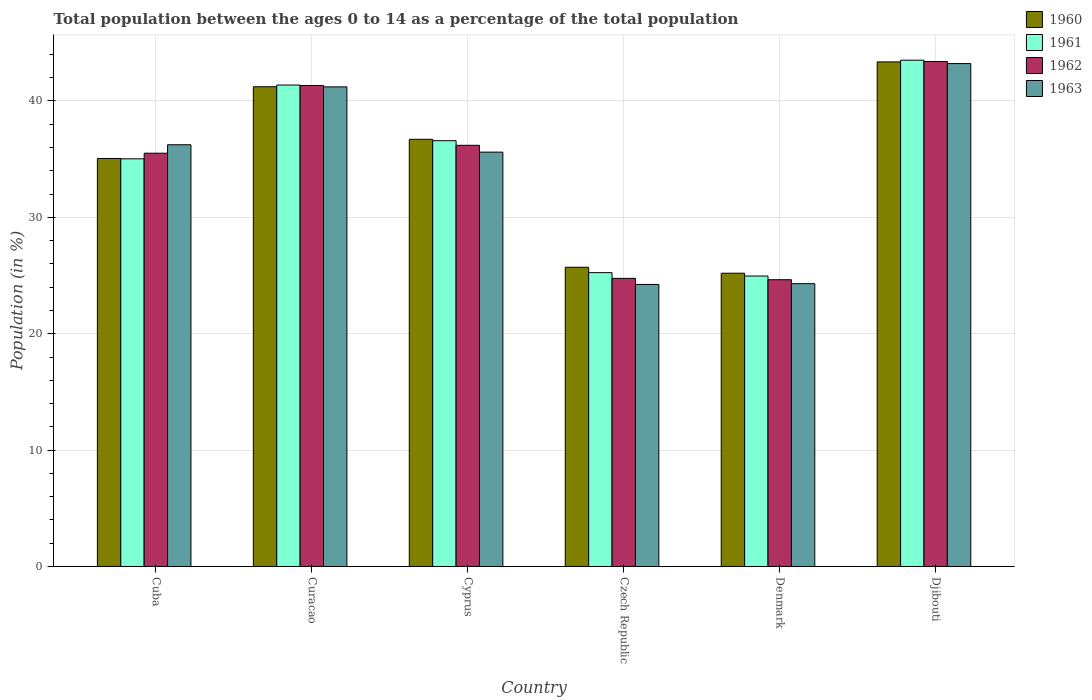How many different coloured bars are there?
Ensure brevity in your answer.  4. How many groups of bars are there?
Ensure brevity in your answer.  6. How many bars are there on the 4th tick from the left?
Provide a succinct answer. 4. How many bars are there on the 6th tick from the right?
Your response must be concise. 4. What is the label of the 1st group of bars from the left?
Keep it short and to the point. Cuba. What is the percentage of the population ages 0 to 14 in 1963 in Cyprus?
Your answer should be compact. 35.6. Across all countries, what is the maximum percentage of the population ages 0 to 14 in 1962?
Your response must be concise. 43.39. Across all countries, what is the minimum percentage of the population ages 0 to 14 in 1961?
Your answer should be very brief. 24.96. In which country was the percentage of the population ages 0 to 14 in 1961 maximum?
Provide a short and direct response. Djibouti. What is the total percentage of the population ages 0 to 14 in 1961 in the graph?
Your answer should be compact. 206.7. What is the difference between the percentage of the population ages 0 to 14 in 1963 in Curacao and that in Djibouti?
Make the answer very short. -2. What is the difference between the percentage of the population ages 0 to 14 in 1963 in Cyprus and the percentage of the population ages 0 to 14 in 1961 in Curacao?
Provide a short and direct response. -5.77. What is the average percentage of the population ages 0 to 14 in 1960 per country?
Make the answer very short. 34.54. What is the difference between the percentage of the population ages 0 to 14 of/in 1961 and percentage of the population ages 0 to 14 of/in 1960 in Cuba?
Offer a very short reply. -0.03. In how many countries, is the percentage of the population ages 0 to 14 in 1963 greater than 10?
Make the answer very short. 6. What is the ratio of the percentage of the population ages 0 to 14 in 1962 in Cuba to that in Cyprus?
Keep it short and to the point. 0.98. Is the percentage of the population ages 0 to 14 in 1963 in Cyprus less than that in Czech Republic?
Offer a very short reply. No. Is the difference between the percentage of the population ages 0 to 14 in 1961 in Czech Republic and Denmark greater than the difference between the percentage of the population ages 0 to 14 in 1960 in Czech Republic and Denmark?
Keep it short and to the point. No. What is the difference between the highest and the second highest percentage of the population ages 0 to 14 in 1963?
Offer a terse response. -2. What is the difference between the highest and the lowest percentage of the population ages 0 to 14 in 1961?
Make the answer very short. 18.55. Is it the case that in every country, the sum of the percentage of the population ages 0 to 14 in 1960 and percentage of the population ages 0 to 14 in 1961 is greater than the sum of percentage of the population ages 0 to 14 in 1962 and percentage of the population ages 0 to 14 in 1963?
Offer a terse response. No. What does the 1st bar from the left in Cuba represents?
Your response must be concise. 1960. What does the 4th bar from the right in Czech Republic represents?
Make the answer very short. 1960. Are all the bars in the graph horizontal?
Offer a very short reply. No. How many countries are there in the graph?
Provide a succinct answer. 6. What is the difference between two consecutive major ticks on the Y-axis?
Keep it short and to the point. 10. What is the title of the graph?
Your response must be concise. Total population between the ages 0 to 14 as a percentage of the total population. Does "1995" appear as one of the legend labels in the graph?
Keep it short and to the point. No. What is the label or title of the X-axis?
Ensure brevity in your answer.  Country. What is the label or title of the Y-axis?
Your answer should be very brief. Population (in %). What is the Population (in %) of 1960 in Cuba?
Make the answer very short. 35.06. What is the Population (in %) in 1961 in Cuba?
Provide a succinct answer. 35.03. What is the Population (in %) of 1962 in Cuba?
Your answer should be compact. 35.51. What is the Population (in %) in 1963 in Cuba?
Offer a terse response. 36.24. What is the Population (in %) of 1960 in Curacao?
Ensure brevity in your answer.  41.22. What is the Population (in %) of 1961 in Curacao?
Your response must be concise. 41.37. What is the Population (in %) of 1962 in Curacao?
Make the answer very short. 41.33. What is the Population (in %) in 1963 in Curacao?
Ensure brevity in your answer.  41.21. What is the Population (in %) in 1960 in Cyprus?
Make the answer very short. 36.71. What is the Population (in %) in 1961 in Cyprus?
Your answer should be compact. 36.59. What is the Population (in %) of 1962 in Cyprus?
Your response must be concise. 36.19. What is the Population (in %) in 1963 in Cyprus?
Provide a short and direct response. 35.6. What is the Population (in %) of 1960 in Czech Republic?
Your answer should be compact. 25.71. What is the Population (in %) of 1961 in Czech Republic?
Ensure brevity in your answer.  25.25. What is the Population (in %) in 1962 in Czech Republic?
Provide a succinct answer. 24.76. What is the Population (in %) in 1963 in Czech Republic?
Make the answer very short. 24.23. What is the Population (in %) in 1960 in Denmark?
Keep it short and to the point. 25.2. What is the Population (in %) in 1961 in Denmark?
Give a very brief answer. 24.96. What is the Population (in %) in 1962 in Denmark?
Make the answer very short. 24.64. What is the Population (in %) of 1963 in Denmark?
Your answer should be very brief. 24.3. What is the Population (in %) in 1960 in Djibouti?
Offer a very short reply. 43.36. What is the Population (in %) in 1961 in Djibouti?
Offer a very short reply. 43.5. What is the Population (in %) of 1962 in Djibouti?
Offer a very short reply. 43.39. What is the Population (in %) of 1963 in Djibouti?
Your response must be concise. 43.21. Across all countries, what is the maximum Population (in %) of 1960?
Ensure brevity in your answer.  43.36. Across all countries, what is the maximum Population (in %) in 1961?
Give a very brief answer. 43.5. Across all countries, what is the maximum Population (in %) in 1962?
Offer a terse response. 43.39. Across all countries, what is the maximum Population (in %) of 1963?
Provide a short and direct response. 43.21. Across all countries, what is the minimum Population (in %) in 1960?
Provide a short and direct response. 25.2. Across all countries, what is the minimum Population (in %) of 1961?
Make the answer very short. 24.96. Across all countries, what is the minimum Population (in %) in 1962?
Make the answer very short. 24.64. Across all countries, what is the minimum Population (in %) in 1963?
Your answer should be compact. 24.23. What is the total Population (in %) in 1960 in the graph?
Your answer should be compact. 207.26. What is the total Population (in %) in 1961 in the graph?
Your answer should be very brief. 206.7. What is the total Population (in %) of 1962 in the graph?
Make the answer very short. 205.82. What is the total Population (in %) of 1963 in the graph?
Provide a succinct answer. 204.8. What is the difference between the Population (in %) in 1960 in Cuba and that in Curacao?
Provide a succinct answer. -6.16. What is the difference between the Population (in %) in 1961 in Cuba and that in Curacao?
Offer a very short reply. -6.34. What is the difference between the Population (in %) in 1962 in Cuba and that in Curacao?
Your answer should be compact. -5.82. What is the difference between the Population (in %) of 1963 in Cuba and that in Curacao?
Give a very brief answer. -4.97. What is the difference between the Population (in %) of 1960 in Cuba and that in Cyprus?
Provide a short and direct response. -1.65. What is the difference between the Population (in %) in 1961 in Cuba and that in Cyprus?
Ensure brevity in your answer.  -1.56. What is the difference between the Population (in %) in 1962 in Cuba and that in Cyprus?
Provide a short and direct response. -0.68. What is the difference between the Population (in %) of 1963 in Cuba and that in Cyprus?
Keep it short and to the point. 0.63. What is the difference between the Population (in %) of 1960 in Cuba and that in Czech Republic?
Keep it short and to the point. 9.35. What is the difference between the Population (in %) in 1961 in Cuba and that in Czech Republic?
Offer a very short reply. 9.78. What is the difference between the Population (in %) in 1962 in Cuba and that in Czech Republic?
Offer a terse response. 10.76. What is the difference between the Population (in %) of 1963 in Cuba and that in Czech Republic?
Make the answer very short. 12. What is the difference between the Population (in %) in 1960 in Cuba and that in Denmark?
Make the answer very short. 9.86. What is the difference between the Population (in %) of 1961 in Cuba and that in Denmark?
Give a very brief answer. 10.07. What is the difference between the Population (in %) of 1962 in Cuba and that in Denmark?
Provide a short and direct response. 10.87. What is the difference between the Population (in %) of 1963 in Cuba and that in Denmark?
Give a very brief answer. 11.94. What is the difference between the Population (in %) of 1960 in Cuba and that in Djibouti?
Ensure brevity in your answer.  -8.3. What is the difference between the Population (in %) in 1961 in Cuba and that in Djibouti?
Offer a terse response. -8.48. What is the difference between the Population (in %) of 1962 in Cuba and that in Djibouti?
Provide a succinct answer. -7.88. What is the difference between the Population (in %) of 1963 in Cuba and that in Djibouti?
Your response must be concise. -6.97. What is the difference between the Population (in %) in 1960 in Curacao and that in Cyprus?
Give a very brief answer. 4.52. What is the difference between the Population (in %) of 1961 in Curacao and that in Cyprus?
Your response must be concise. 4.78. What is the difference between the Population (in %) of 1962 in Curacao and that in Cyprus?
Make the answer very short. 5.14. What is the difference between the Population (in %) in 1963 in Curacao and that in Cyprus?
Your answer should be very brief. 5.61. What is the difference between the Population (in %) in 1960 in Curacao and that in Czech Republic?
Make the answer very short. 15.51. What is the difference between the Population (in %) in 1961 in Curacao and that in Czech Republic?
Ensure brevity in your answer.  16.12. What is the difference between the Population (in %) of 1962 in Curacao and that in Czech Republic?
Your answer should be very brief. 16.57. What is the difference between the Population (in %) of 1963 in Curacao and that in Czech Republic?
Provide a short and direct response. 16.98. What is the difference between the Population (in %) in 1960 in Curacao and that in Denmark?
Your answer should be compact. 16.02. What is the difference between the Population (in %) of 1961 in Curacao and that in Denmark?
Your answer should be very brief. 16.41. What is the difference between the Population (in %) of 1962 in Curacao and that in Denmark?
Offer a terse response. 16.69. What is the difference between the Population (in %) of 1963 in Curacao and that in Denmark?
Your response must be concise. 16.91. What is the difference between the Population (in %) of 1960 in Curacao and that in Djibouti?
Give a very brief answer. -2.14. What is the difference between the Population (in %) of 1961 in Curacao and that in Djibouti?
Provide a succinct answer. -2.13. What is the difference between the Population (in %) of 1962 in Curacao and that in Djibouti?
Keep it short and to the point. -2.06. What is the difference between the Population (in %) of 1963 in Curacao and that in Djibouti?
Offer a very short reply. -2. What is the difference between the Population (in %) of 1960 in Cyprus and that in Czech Republic?
Keep it short and to the point. 11. What is the difference between the Population (in %) of 1961 in Cyprus and that in Czech Republic?
Provide a short and direct response. 11.34. What is the difference between the Population (in %) in 1962 in Cyprus and that in Czech Republic?
Ensure brevity in your answer.  11.43. What is the difference between the Population (in %) of 1963 in Cyprus and that in Czech Republic?
Make the answer very short. 11.37. What is the difference between the Population (in %) of 1960 in Cyprus and that in Denmark?
Provide a short and direct response. 11.51. What is the difference between the Population (in %) of 1961 in Cyprus and that in Denmark?
Ensure brevity in your answer.  11.63. What is the difference between the Population (in %) in 1962 in Cyprus and that in Denmark?
Offer a very short reply. 11.55. What is the difference between the Population (in %) in 1963 in Cyprus and that in Denmark?
Provide a succinct answer. 11.3. What is the difference between the Population (in %) in 1960 in Cyprus and that in Djibouti?
Make the answer very short. -6.65. What is the difference between the Population (in %) in 1961 in Cyprus and that in Djibouti?
Provide a short and direct response. -6.92. What is the difference between the Population (in %) in 1962 in Cyprus and that in Djibouti?
Your answer should be very brief. -7.2. What is the difference between the Population (in %) of 1963 in Cyprus and that in Djibouti?
Provide a succinct answer. -7.61. What is the difference between the Population (in %) in 1960 in Czech Republic and that in Denmark?
Your answer should be compact. 0.51. What is the difference between the Population (in %) in 1961 in Czech Republic and that in Denmark?
Offer a very short reply. 0.29. What is the difference between the Population (in %) of 1962 in Czech Republic and that in Denmark?
Make the answer very short. 0.12. What is the difference between the Population (in %) in 1963 in Czech Republic and that in Denmark?
Ensure brevity in your answer.  -0.07. What is the difference between the Population (in %) in 1960 in Czech Republic and that in Djibouti?
Offer a terse response. -17.65. What is the difference between the Population (in %) in 1961 in Czech Republic and that in Djibouti?
Offer a terse response. -18.26. What is the difference between the Population (in %) of 1962 in Czech Republic and that in Djibouti?
Provide a short and direct response. -18.64. What is the difference between the Population (in %) in 1963 in Czech Republic and that in Djibouti?
Ensure brevity in your answer.  -18.98. What is the difference between the Population (in %) of 1960 in Denmark and that in Djibouti?
Ensure brevity in your answer.  -18.16. What is the difference between the Population (in %) of 1961 in Denmark and that in Djibouti?
Provide a succinct answer. -18.55. What is the difference between the Population (in %) of 1962 in Denmark and that in Djibouti?
Make the answer very short. -18.75. What is the difference between the Population (in %) of 1963 in Denmark and that in Djibouti?
Offer a very short reply. -18.91. What is the difference between the Population (in %) in 1960 in Cuba and the Population (in %) in 1961 in Curacao?
Your response must be concise. -6.31. What is the difference between the Population (in %) in 1960 in Cuba and the Population (in %) in 1962 in Curacao?
Your answer should be compact. -6.27. What is the difference between the Population (in %) in 1960 in Cuba and the Population (in %) in 1963 in Curacao?
Offer a very short reply. -6.15. What is the difference between the Population (in %) of 1961 in Cuba and the Population (in %) of 1962 in Curacao?
Keep it short and to the point. -6.3. What is the difference between the Population (in %) of 1961 in Cuba and the Population (in %) of 1963 in Curacao?
Keep it short and to the point. -6.18. What is the difference between the Population (in %) of 1960 in Cuba and the Population (in %) of 1961 in Cyprus?
Offer a very short reply. -1.53. What is the difference between the Population (in %) of 1960 in Cuba and the Population (in %) of 1962 in Cyprus?
Make the answer very short. -1.13. What is the difference between the Population (in %) in 1960 in Cuba and the Population (in %) in 1963 in Cyprus?
Keep it short and to the point. -0.54. What is the difference between the Population (in %) in 1961 in Cuba and the Population (in %) in 1962 in Cyprus?
Ensure brevity in your answer.  -1.16. What is the difference between the Population (in %) in 1961 in Cuba and the Population (in %) in 1963 in Cyprus?
Offer a very short reply. -0.58. What is the difference between the Population (in %) of 1962 in Cuba and the Population (in %) of 1963 in Cyprus?
Offer a very short reply. -0.09. What is the difference between the Population (in %) in 1960 in Cuba and the Population (in %) in 1961 in Czech Republic?
Your answer should be compact. 9.81. What is the difference between the Population (in %) in 1960 in Cuba and the Population (in %) in 1962 in Czech Republic?
Your response must be concise. 10.3. What is the difference between the Population (in %) of 1960 in Cuba and the Population (in %) of 1963 in Czech Republic?
Your response must be concise. 10.83. What is the difference between the Population (in %) of 1961 in Cuba and the Population (in %) of 1962 in Czech Republic?
Provide a short and direct response. 10.27. What is the difference between the Population (in %) in 1961 in Cuba and the Population (in %) in 1963 in Czech Republic?
Make the answer very short. 10.79. What is the difference between the Population (in %) of 1962 in Cuba and the Population (in %) of 1963 in Czech Republic?
Your response must be concise. 11.28. What is the difference between the Population (in %) of 1960 in Cuba and the Population (in %) of 1961 in Denmark?
Give a very brief answer. 10.1. What is the difference between the Population (in %) of 1960 in Cuba and the Population (in %) of 1962 in Denmark?
Keep it short and to the point. 10.42. What is the difference between the Population (in %) in 1960 in Cuba and the Population (in %) in 1963 in Denmark?
Your response must be concise. 10.76. What is the difference between the Population (in %) in 1961 in Cuba and the Population (in %) in 1962 in Denmark?
Your answer should be very brief. 10.39. What is the difference between the Population (in %) in 1961 in Cuba and the Population (in %) in 1963 in Denmark?
Your response must be concise. 10.73. What is the difference between the Population (in %) in 1962 in Cuba and the Population (in %) in 1963 in Denmark?
Offer a very short reply. 11.21. What is the difference between the Population (in %) of 1960 in Cuba and the Population (in %) of 1961 in Djibouti?
Offer a very short reply. -8.44. What is the difference between the Population (in %) of 1960 in Cuba and the Population (in %) of 1962 in Djibouti?
Provide a short and direct response. -8.33. What is the difference between the Population (in %) of 1960 in Cuba and the Population (in %) of 1963 in Djibouti?
Your answer should be very brief. -8.15. What is the difference between the Population (in %) of 1961 in Cuba and the Population (in %) of 1962 in Djibouti?
Your response must be concise. -8.36. What is the difference between the Population (in %) of 1961 in Cuba and the Population (in %) of 1963 in Djibouti?
Keep it short and to the point. -8.18. What is the difference between the Population (in %) in 1962 in Cuba and the Population (in %) in 1963 in Djibouti?
Ensure brevity in your answer.  -7.7. What is the difference between the Population (in %) in 1960 in Curacao and the Population (in %) in 1961 in Cyprus?
Your answer should be compact. 4.64. What is the difference between the Population (in %) of 1960 in Curacao and the Population (in %) of 1962 in Cyprus?
Your response must be concise. 5.03. What is the difference between the Population (in %) in 1960 in Curacao and the Population (in %) in 1963 in Cyprus?
Your answer should be very brief. 5.62. What is the difference between the Population (in %) of 1961 in Curacao and the Population (in %) of 1962 in Cyprus?
Your response must be concise. 5.18. What is the difference between the Population (in %) of 1961 in Curacao and the Population (in %) of 1963 in Cyprus?
Offer a terse response. 5.77. What is the difference between the Population (in %) in 1962 in Curacao and the Population (in %) in 1963 in Cyprus?
Ensure brevity in your answer.  5.72. What is the difference between the Population (in %) in 1960 in Curacao and the Population (in %) in 1961 in Czech Republic?
Provide a succinct answer. 15.97. What is the difference between the Population (in %) in 1960 in Curacao and the Population (in %) in 1962 in Czech Republic?
Provide a short and direct response. 16.47. What is the difference between the Population (in %) of 1960 in Curacao and the Population (in %) of 1963 in Czech Republic?
Your response must be concise. 16.99. What is the difference between the Population (in %) of 1961 in Curacao and the Population (in %) of 1962 in Czech Republic?
Offer a very short reply. 16.61. What is the difference between the Population (in %) of 1961 in Curacao and the Population (in %) of 1963 in Czech Republic?
Provide a succinct answer. 17.14. What is the difference between the Population (in %) in 1962 in Curacao and the Population (in %) in 1963 in Czech Republic?
Offer a terse response. 17.09. What is the difference between the Population (in %) in 1960 in Curacao and the Population (in %) in 1961 in Denmark?
Offer a terse response. 16.26. What is the difference between the Population (in %) of 1960 in Curacao and the Population (in %) of 1962 in Denmark?
Offer a terse response. 16.58. What is the difference between the Population (in %) in 1960 in Curacao and the Population (in %) in 1963 in Denmark?
Give a very brief answer. 16.92. What is the difference between the Population (in %) of 1961 in Curacao and the Population (in %) of 1962 in Denmark?
Your response must be concise. 16.73. What is the difference between the Population (in %) in 1961 in Curacao and the Population (in %) in 1963 in Denmark?
Your response must be concise. 17.07. What is the difference between the Population (in %) of 1962 in Curacao and the Population (in %) of 1963 in Denmark?
Ensure brevity in your answer.  17.03. What is the difference between the Population (in %) in 1960 in Curacao and the Population (in %) in 1961 in Djibouti?
Offer a terse response. -2.28. What is the difference between the Population (in %) of 1960 in Curacao and the Population (in %) of 1962 in Djibouti?
Provide a short and direct response. -2.17. What is the difference between the Population (in %) of 1960 in Curacao and the Population (in %) of 1963 in Djibouti?
Your answer should be compact. -1.99. What is the difference between the Population (in %) of 1961 in Curacao and the Population (in %) of 1962 in Djibouti?
Make the answer very short. -2.02. What is the difference between the Population (in %) of 1961 in Curacao and the Population (in %) of 1963 in Djibouti?
Offer a very short reply. -1.84. What is the difference between the Population (in %) in 1962 in Curacao and the Population (in %) in 1963 in Djibouti?
Your answer should be compact. -1.88. What is the difference between the Population (in %) of 1960 in Cyprus and the Population (in %) of 1961 in Czech Republic?
Provide a succinct answer. 11.46. What is the difference between the Population (in %) of 1960 in Cyprus and the Population (in %) of 1962 in Czech Republic?
Give a very brief answer. 11.95. What is the difference between the Population (in %) in 1960 in Cyprus and the Population (in %) in 1963 in Czech Republic?
Make the answer very short. 12.47. What is the difference between the Population (in %) of 1961 in Cyprus and the Population (in %) of 1962 in Czech Republic?
Your answer should be very brief. 11.83. What is the difference between the Population (in %) in 1961 in Cyprus and the Population (in %) in 1963 in Czech Republic?
Make the answer very short. 12.35. What is the difference between the Population (in %) of 1962 in Cyprus and the Population (in %) of 1963 in Czech Republic?
Ensure brevity in your answer.  11.96. What is the difference between the Population (in %) in 1960 in Cyprus and the Population (in %) in 1961 in Denmark?
Make the answer very short. 11.75. What is the difference between the Population (in %) in 1960 in Cyprus and the Population (in %) in 1962 in Denmark?
Your answer should be compact. 12.07. What is the difference between the Population (in %) of 1960 in Cyprus and the Population (in %) of 1963 in Denmark?
Offer a very short reply. 12.41. What is the difference between the Population (in %) of 1961 in Cyprus and the Population (in %) of 1962 in Denmark?
Offer a terse response. 11.95. What is the difference between the Population (in %) in 1961 in Cyprus and the Population (in %) in 1963 in Denmark?
Your answer should be compact. 12.29. What is the difference between the Population (in %) of 1962 in Cyprus and the Population (in %) of 1963 in Denmark?
Give a very brief answer. 11.89. What is the difference between the Population (in %) in 1960 in Cyprus and the Population (in %) in 1961 in Djibouti?
Ensure brevity in your answer.  -6.8. What is the difference between the Population (in %) in 1960 in Cyprus and the Population (in %) in 1962 in Djibouti?
Your answer should be compact. -6.69. What is the difference between the Population (in %) in 1960 in Cyprus and the Population (in %) in 1963 in Djibouti?
Your answer should be very brief. -6.51. What is the difference between the Population (in %) of 1961 in Cyprus and the Population (in %) of 1962 in Djibouti?
Your answer should be very brief. -6.81. What is the difference between the Population (in %) of 1961 in Cyprus and the Population (in %) of 1963 in Djibouti?
Give a very brief answer. -6.63. What is the difference between the Population (in %) of 1962 in Cyprus and the Population (in %) of 1963 in Djibouti?
Your answer should be very brief. -7.02. What is the difference between the Population (in %) in 1960 in Czech Republic and the Population (in %) in 1961 in Denmark?
Your answer should be compact. 0.75. What is the difference between the Population (in %) of 1960 in Czech Republic and the Population (in %) of 1962 in Denmark?
Offer a terse response. 1.07. What is the difference between the Population (in %) in 1960 in Czech Republic and the Population (in %) in 1963 in Denmark?
Your answer should be compact. 1.41. What is the difference between the Population (in %) in 1961 in Czech Republic and the Population (in %) in 1962 in Denmark?
Keep it short and to the point. 0.61. What is the difference between the Population (in %) in 1961 in Czech Republic and the Population (in %) in 1963 in Denmark?
Keep it short and to the point. 0.95. What is the difference between the Population (in %) of 1962 in Czech Republic and the Population (in %) of 1963 in Denmark?
Your response must be concise. 0.46. What is the difference between the Population (in %) of 1960 in Czech Republic and the Population (in %) of 1961 in Djibouti?
Make the answer very short. -17.79. What is the difference between the Population (in %) of 1960 in Czech Republic and the Population (in %) of 1962 in Djibouti?
Keep it short and to the point. -17.68. What is the difference between the Population (in %) of 1960 in Czech Republic and the Population (in %) of 1963 in Djibouti?
Offer a terse response. -17.5. What is the difference between the Population (in %) of 1961 in Czech Republic and the Population (in %) of 1962 in Djibouti?
Offer a very short reply. -18.14. What is the difference between the Population (in %) in 1961 in Czech Republic and the Population (in %) in 1963 in Djibouti?
Your answer should be very brief. -17.96. What is the difference between the Population (in %) in 1962 in Czech Republic and the Population (in %) in 1963 in Djibouti?
Offer a terse response. -18.46. What is the difference between the Population (in %) of 1960 in Denmark and the Population (in %) of 1961 in Djibouti?
Your answer should be very brief. -18.3. What is the difference between the Population (in %) in 1960 in Denmark and the Population (in %) in 1962 in Djibouti?
Your answer should be very brief. -18.19. What is the difference between the Population (in %) in 1960 in Denmark and the Population (in %) in 1963 in Djibouti?
Give a very brief answer. -18.01. What is the difference between the Population (in %) of 1961 in Denmark and the Population (in %) of 1962 in Djibouti?
Your answer should be very brief. -18.43. What is the difference between the Population (in %) of 1961 in Denmark and the Population (in %) of 1963 in Djibouti?
Ensure brevity in your answer.  -18.25. What is the difference between the Population (in %) of 1962 in Denmark and the Population (in %) of 1963 in Djibouti?
Offer a very short reply. -18.57. What is the average Population (in %) of 1960 per country?
Your answer should be very brief. 34.54. What is the average Population (in %) in 1961 per country?
Your response must be concise. 34.45. What is the average Population (in %) in 1962 per country?
Offer a very short reply. 34.3. What is the average Population (in %) of 1963 per country?
Offer a very short reply. 34.13. What is the difference between the Population (in %) of 1960 and Population (in %) of 1961 in Cuba?
Provide a short and direct response. 0.03. What is the difference between the Population (in %) of 1960 and Population (in %) of 1962 in Cuba?
Ensure brevity in your answer.  -0.45. What is the difference between the Population (in %) in 1960 and Population (in %) in 1963 in Cuba?
Provide a succinct answer. -1.18. What is the difference between the Population (in %) of 1961 and Population (in %) of 1962 in Cuba?
Provide a short and direct response. -0.48. What is the difference between the Population (in %) in 1961 and Population (in %) in 1963 in Cuba?
Offer a very short reply. -1.21. What is the difference between the Population (in %) of 1962 and Population (in %) of 1963 in Cuba?
Your response must be concise. -0.73. What is the difference between the Population (in %) of 1960 and Population (in %) of 1961 in Curacao?
Your answer should be compact. -0.15. What is the difference between the Population (in %) in 1960 and Population (in %) in 1962 in Curacao?
Make the answer very short. -0.11. What is the difference between the Population (in %) of 1960 and Population (in %) of 1963 in Curacao?
Provide a succinct answer. 0.01. What is the difference between the Population (in %) in 1961 and Population (in %) in 1962 in Curacao?
Your answer should be very brief. 0.04. What is the difference between the Population (in %) in 1961 and Population (in %) in 1963 in Curacao?
Keep it short and to the point. 0.16. What is the difference between the Population (in %) of 1962 and Population (in %) of 1963 in Curacao?
Make the answer very short. 0.12. What is the difference between the Population (in %) of 1960 and Population (in %) of 1961 in Cyprus?
Your answer should be very brief. 0.12. What is the difference between the Population (in %) in 1960 and Population (in %) in 1962 in Cyprus?
Make the answer very short. 0.52. What is the difference between the Population (in %) in 1960 and Population (in %) in 1963 in Cyprus?
Your response must be concise. 1.1. What is the difference between the Population (in %) of 1961 and Population (in %) of 1962 in Cyprus?
Give a very brief answer. 0.4. What is the difference between the Population (in %) in 1961 and Population (in %) in 1963 in Cyprus?
Keep it short and to the point. 0.98. What is the difference between the Population (in %) in 1962 and Population (in %) in 1963 in Cyprus?
Your answer should be very brief. 0.59. What is the difference between the Population (in %) of 1960 and Population (in %) of 1961 in Czech Republic?
Provide a short and direct response. 0.46. What is the difference between the Population (in %) in 1960 and Population (in %) in 1962 in Czech Republic?
Your answer should be very brief. 0.95. What is the difference between the Population (in %) in 1960 and Population (in %) in 1963 in Czech Republic?
Give a very brief answer. 1.48. What is the difference between the Population (in %) of 1961 and Population (in %) of 1962 in Czech Republic?
Your answer should be very brief. 0.49. What is the difference between the Population (in %) in 1961 and Population (in %) in 1963 in Czech Republic?
Your answer should be compact. 1.01. What is the difference between the Population (in %) in 1962 and Population (in %) in 1963 in Czech Republic?
Make the answer very short. 0.52. What is the difference between the Population (in %) in 1960 and Population (in %) in 1961 in Denmark?
Make the answer very short. 0.24. What is the difference between the Population (in %) in 1960 and Population (in %) in 1962 in Denmark?
Offer a terse response. 0.56. What is the difference between the Population (in %) in 1960 and Population (in %) in 1963 in Denmark?
Give a very brief answer. 0.9. What is the difference between the Population (in %) of 1961 and Population (in %) of 1962 in Denmark?
Your response must be concise. 0.32. What is the difference between the Population (in %) in 1961 and Population (in %) in 1963 in Denmark?
Provide a succinct answer. 0.66. What is the difference between the Population (in %) in 1962 and Population (in %) in 1963 in Denmark?
Provide a short and direct response. 0.34. What is the difference between the Population (in %) of 1960 and Population (in %) of 1961 in Djibouti?
Offer a terse response. -0.15. What is the difference between the Population (in %) of 1960 and Population (in %) of 1962 in Djibouti?
Make the answer very short. -0.03. What is the difference between the Population (in %) of 1960 and Population (in %) of 1963 in Djibouti?
Give a very brief answer. 0.14. What is the difference between the Population (in %) of 1961 and Population (in %) of 1962 in Djibouti?
Provide a succinct answer. 0.11. What is the difference between the Population (in %) of 1961 and Population (in %) of 1963 in Djibouti?
Your answer should be very brief. 0.29. What is the difference between the Population (in %) in 1962 and Population (in %) in 1963 in Djibouti?
Offer a terse response. 0.18. What is the ratio of the Population (in %) in 1960 in Cuba to that in Curacao?
Give a very brief answer. 0.85. What is the ratio of the Population (in %) of 1961 in Cuba to that in Curacao?
Your answer should be compact. 0.85. What is the ratio of the Population (in %) in 1962 in Cuba to that in Curacao?
Provide a short and direct response. 0.86. What is the ratio of the Population (in %) in 1963 in Cuba to that in Curacao?
Your response must be concise. 0.88. What is the ratio of the Population (in %) of 1960 in Cuba to that in Cyprus?
Provide a succinct answer. 0.96. What is the ratio of the Population (in %) in 1961 in Cuba to that in Cyprus?
Provide a short and direct response. 0.96. What is the ratio of the Population (in %) in 1962 in Cuba to that in Cyprus?
Provide a short and direct response. 0.98. What is the ratio of the Population (in %) in 1963 in Cuba to that in Cyprus?
Your response must be concise. 1.02. What is the ratio of the Population (in %) of 1960 in Cuba to that in Czech Republic?
Your answer should be compact. 1.36. What is the ratio of the Population (in %) of 1961 in Cuba to that in Czech Republic?
Your response must be concise. 1.39. What is the ratio of the Population (in %) of 1962 in Cuba to that in Czech Republic?
Keep it short and to the point. 1.43. What is the ratio of the Population (in %) in 1963 in Cuba to that in Czech Republic?
Provide a short and direct response. 1.5. What is the ratio of the Population (in %) of 1960 in Cuba to that in Denmark?
Make the answer very short. 1.39. What is the ratio of the Population (in %) in 1961 in Cuba to that in Denmark?
Your answer should be very brief. 1.4. What is the ratio of the Population (in %) of 1962 in Cuba to that in Denmark?
Make the answer very short. 1.44. What is the ratio of the Population (in %) of 1963 in Cuba to that in Denmark?
Provide a short and direct response. 1.49. What is the ratio of the Population (in %) in 1960 in Cuba to that in Djibouti?
Make the answer very short. 0.81. What is the ratio of the Population (in %) in 1961 in Cuba to that in Djibouti?
Give a very brief answer. 0.81. What is the ratio of the Population (in %) in 1962 in Cuba to that in Djibouti?
Offer a very short reply. 0.82. What is the ratio of the Population (in %) of 1963 in Cuba to that in Djibouti?
Your answer should be compact. 0.84. What is the ratio of the Population (in %) of 1960 in Curacao to that in Cyprus?
Make the answer very short. 1.12. What is the ratio of the Population (in %) of 1961 in Curacao to that in Cyprus?
Offer a terse response. 1.13. What is the ratio of the Population (in %) in 1962 in Curacao to that in Cyprus?
Provide a short and direct response. 1.14. What is the ratio of the Population (in %) of 1963 in Curacao to that in Cyprus?
Provide a short and direct response. 1.16. What is the ratio of the Population (in %) of 1960 in Curacao to that in Czech Republic?
Ensure brevity in your answer.  1.6. What is the ratio of the Population (in %) in 1961 in Curacao to that in Czech Republic?
Provide a succinct answer. 1.64. What is the ratio of the Population (in %) in 1962 in Curacao to that in Czech Republic?
Your answer should be very brief. 1.67. What is the ratio of the Population (in %) in 1963 in Curacao to that in Czech Republic?
Offer a terse response. 1.7. What is the ratio of the Population (in %) of 1960 in Curacao to that in Denmark?
Provide a short and direct response. 1.64. What is the ratio of the Population (in %) in 1961 in Curacao to that in Denmark?
Your answer should be compact. 1.66. What is the ratio of the Population (in %) of 1962 in Curacao to that in Denmark?
Ensure brevity in your answer.  1.68. What is the ratio of the Population (in %) of 1963 in Curacao to that in Denmark?
Offer a very short reply. 1.7. What is the ratio of the Population (in %) in 1960 in Curacao to that in Djibouti?
Your answer should be very brief. 0.95. What is the ratio of the Population (in %) in 1961 in Curacao to that in Djibouti?
Your answer should be compact. 0.95. What is the ratio of the Population (in %) in 1962 in Curacao to that in Djibouti?
Give a very brief answer. 0.95. What is the ratio of the Population (in %) of 1963 in Curacao to that in Djibouti?
Provide a succinct answer. 0.95. What is the ratio of the Population (in %) in 1960 in Cyprus to that in Czech Republic?
Your answer should be very brief. 1.43. What is the ratio of the Population (in %) in 1961 in Cyprus to that in Czech Republic?
Make the answer very short. 1.45. What is the ratio of the Population (in %) in 1962 in Cyprus to that in Czech Republic?
Offer a very short reply. 1.46. What is the ratio of the Population (in %) in 1963 in Cyprus to that in Czech Republic?
Your answer should be compact. 1.47. What is the ratio of the Population (in %) in 1960 in Cyprus to that in Denmark?
Your answer should be very brief. 1.46. What is the ratio of the Population (in %) of 1961 in Cyprus to that in Denmark?
Your response must be concise. 1.47. What is the ratio of the Population (in %) of 1962 in Cyprus to that in Denmark?
Keep it short and to the point. 1.47. What is the ratio of the Population (in %) in 1963 in Cyprus to that in Denmark?
Make the answer very short. 1.47. What is the ratio of the Population (in %) of 1960 in Cyprus to that in Djibouti?
Keep it short and to the point. 0.85. What is the ratio of the Population (in %) in 1961 in Cyprus to that in Djibouti?
Offer a very short reply. 0.84. What is the ratio of the Population (in %) in 1962 in Cyprus to that in Djibouti?
Offer a terse response. 0.83. What is the ratio of the Population (in %) in 1963 in Cyprus to that in Djibouti?
Your answer should be compact. 0.82. What is the ratio of the Population (in %) in 1960 in Czech Republic to that in Denmark?
Ensure brevity in your answer.  1.02. What is the ratio of the Population (in %) of 1961 in Czech Republic to that in Denmark?
Make the answer very short. 1.01. What is the ratio of the Population (in %) of 1962 in Czech Republic to that in Denmark?
Give a very brief answer. 1. What is the ratio of the Population (in %) in 1963 in Czech Republic to that in Denmark?
Your answer should be compact. 1. What is the ratio of the Population (in %) in 1960 in Czech Republic to that in Djibouti?
Keep it short and to the point. 0.59. What is the ratio of the Population (in %) in 1961 in Czech Republic to that in Djibouti?
Provide a short and direct response. 0.58. What is the ratio of the Population (in %) in 1962 in Czech Republic to that in Djibouti?
Your answer should be very brief. 0.57. What is the ratio of the Population (in %) of 1963 in Czech Republic to that in Djibouti?
Keep it short and to the point. 0.56. What is the ratio of the Population (in %) of 1960 in Denmark to that in Djibouti?
Your answer should be very brief. 0.58. What is the ratio of the Population (in %) of 1961 in Denmark to that in Djibouti?
Offer a terse response. 0.57. What is the ratio of the Population (in %) of 1962 in Denmark to that in Djibouti?
Your answer should be compact. 0.57. What is the ratio of the Population (in %) in 1963 in Denmark to that in Djibouti?
Your answer should be compact. 0.56. What is the difference between the highest and the second highest Population (in %) in 1960?
Give a very brief answer. 2.14. What is the difference between the highest and the second highest Population (in %) of 1961?
Ensure brevity in your answer.  2.13. What is the difference between the highest and the second highest Population (in %) in 1962?
Provide a succinct answer. 2.06. What is the difference between the highest and the second highest Population (in %) in 1963?
Your response must be concise. 2. What is the difference between the highest and the lowest Population (in %) of 1960?
Provide a succinct answer. 18.16. What is the difference between the highest and the lowest Population (in %) of 1961?
Provide a short and direct response. 18.55. What is the difference between the highest and the lowest Population (in %) in 1962?
Provide a short and direct response. 18.75. What is the difference between the highest and the lowest Population (in %) in 1963?
Offer a terse response. 18.98. 